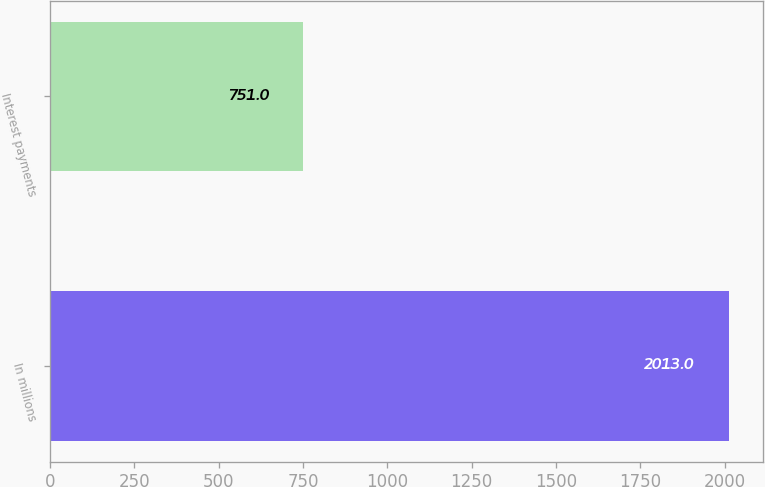Convert chart. <chart><loc_0><loc_0><loc_500><loc_500><bar_chart><fcel>In millions<fcel>Interest payments<nl><fcel>2013<fcel>751<nl></chart> 